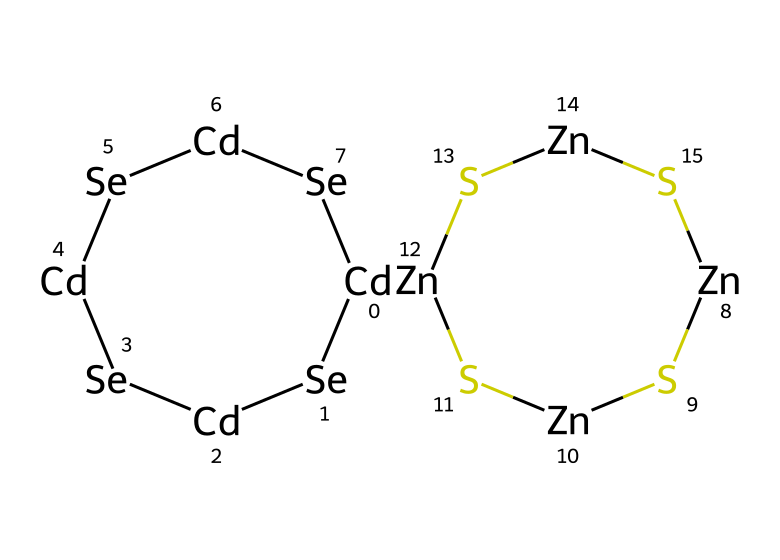How many cadmium atoms are present in this quantum dot? In the provided SMILES structure, "[Cd]" appears four times, indicating there are four cadmium atoms in the chemical structure.
Answer: four What is the primary purpose of these quantum dots? Quantum dots are primarily used for their luminescent properties, making them suitable for applications such as glowing puppet eyes.
Answer: luminescence How many zinc atoms are present in the chemical structure? The "[Zn]" appears four times in the SMILES notation, which shows that there are four zinc atoms in the chemical.
Answer: four Which type of chemical bond connects the cadmium and selenium atoms? The bonds between cadmium and selenium are covalent bonds, typical for semiconductor materials that form quantum dots.
Answer: covalent What family of materials do these quantum dots belong to? The presence of cadmium and selenium suggests that this quantum dot is a member of the II-VI semiconductor family commonly used in luminescent applications.
Answer: II-VI semiconductors How does the arrangement of atoms affect the light emission of these quantum dots? The size, shape, and arrangement of the cadmium and selenium atoms in quantum dots directly influence their electronic and optical properties, including the color of light emitted.
Answer: color emission What is the role of sulfur in this quantum dot formulation? Sulfur acts as a stabilizing agent and can influence the electronic properties of the quantum dot, helping to enhance their luminescent efficiency.
Answer: stabilizer 